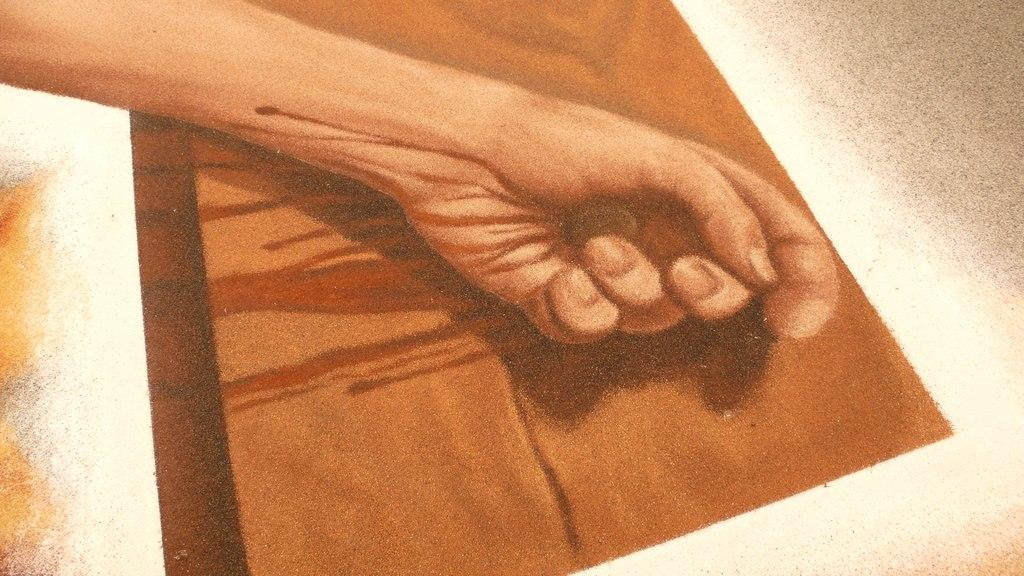What part of a person can be seen in the image? There is a hand of a person in the image. What is the hand holding or touching? There is an object inside the person's hand. What else can be seen under the hand in the image? There is an object under the hand in the image. What rhythm is the hand tapping out on the object under it in the image? There is no indication of rhythm or tapping in the image; the hand is simply holding an object and there is another object under it. 